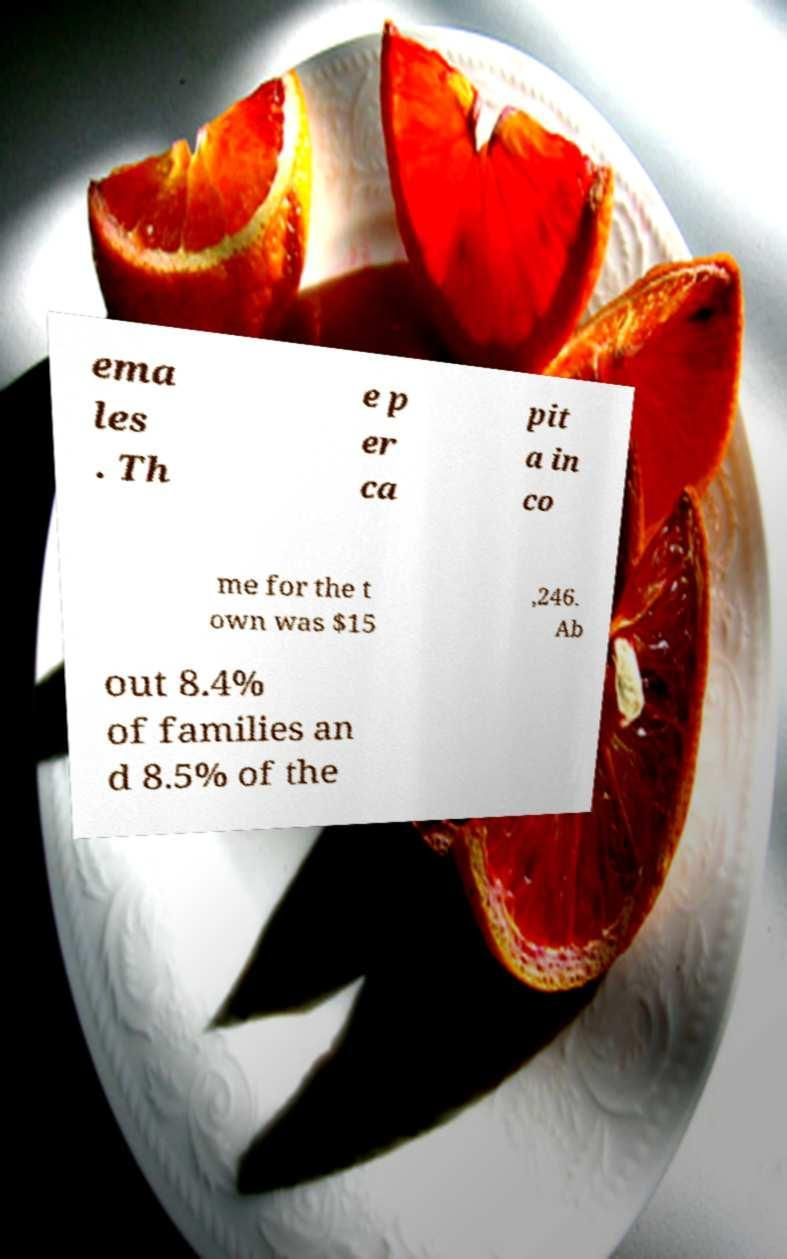There's text embedded in this image that I need extracted. Can you transcribe it verbatim? ema les . Th e p er ca pit a in co me for the t own was $15 ,246. Ab out 8.4% of families an d 8.5% of the 